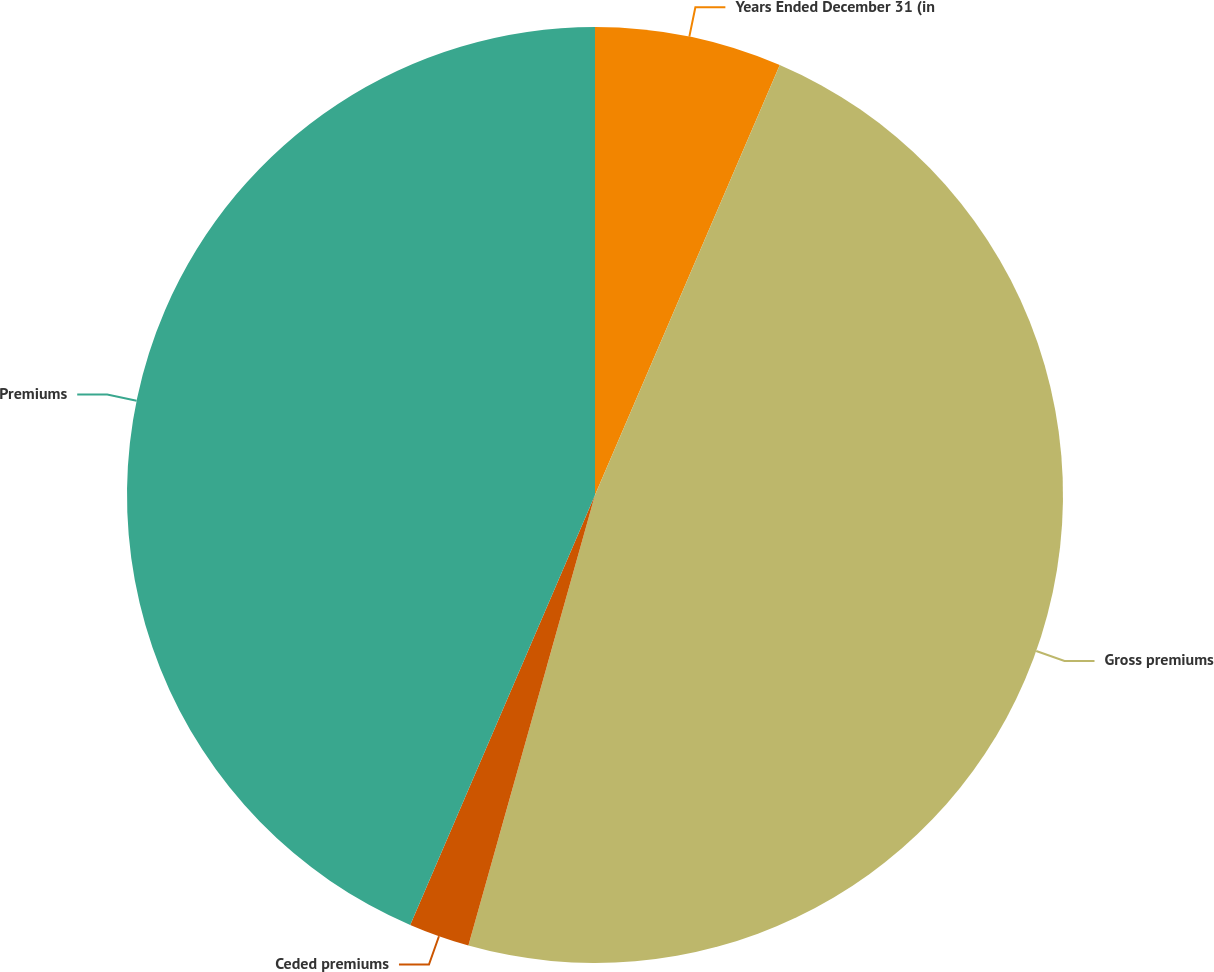<chart> <loc_0><loc_0><loc_500><loc_500><pie_chart><fcel>Years Ended December 31 (in<fcel>Gross premiums<fcel>Ceded premiums<fcel>Premiums<nl><fcel>6.46%<fcel>47.9%<fcel>2.1%<fcel>43.54%<nl></chart> 